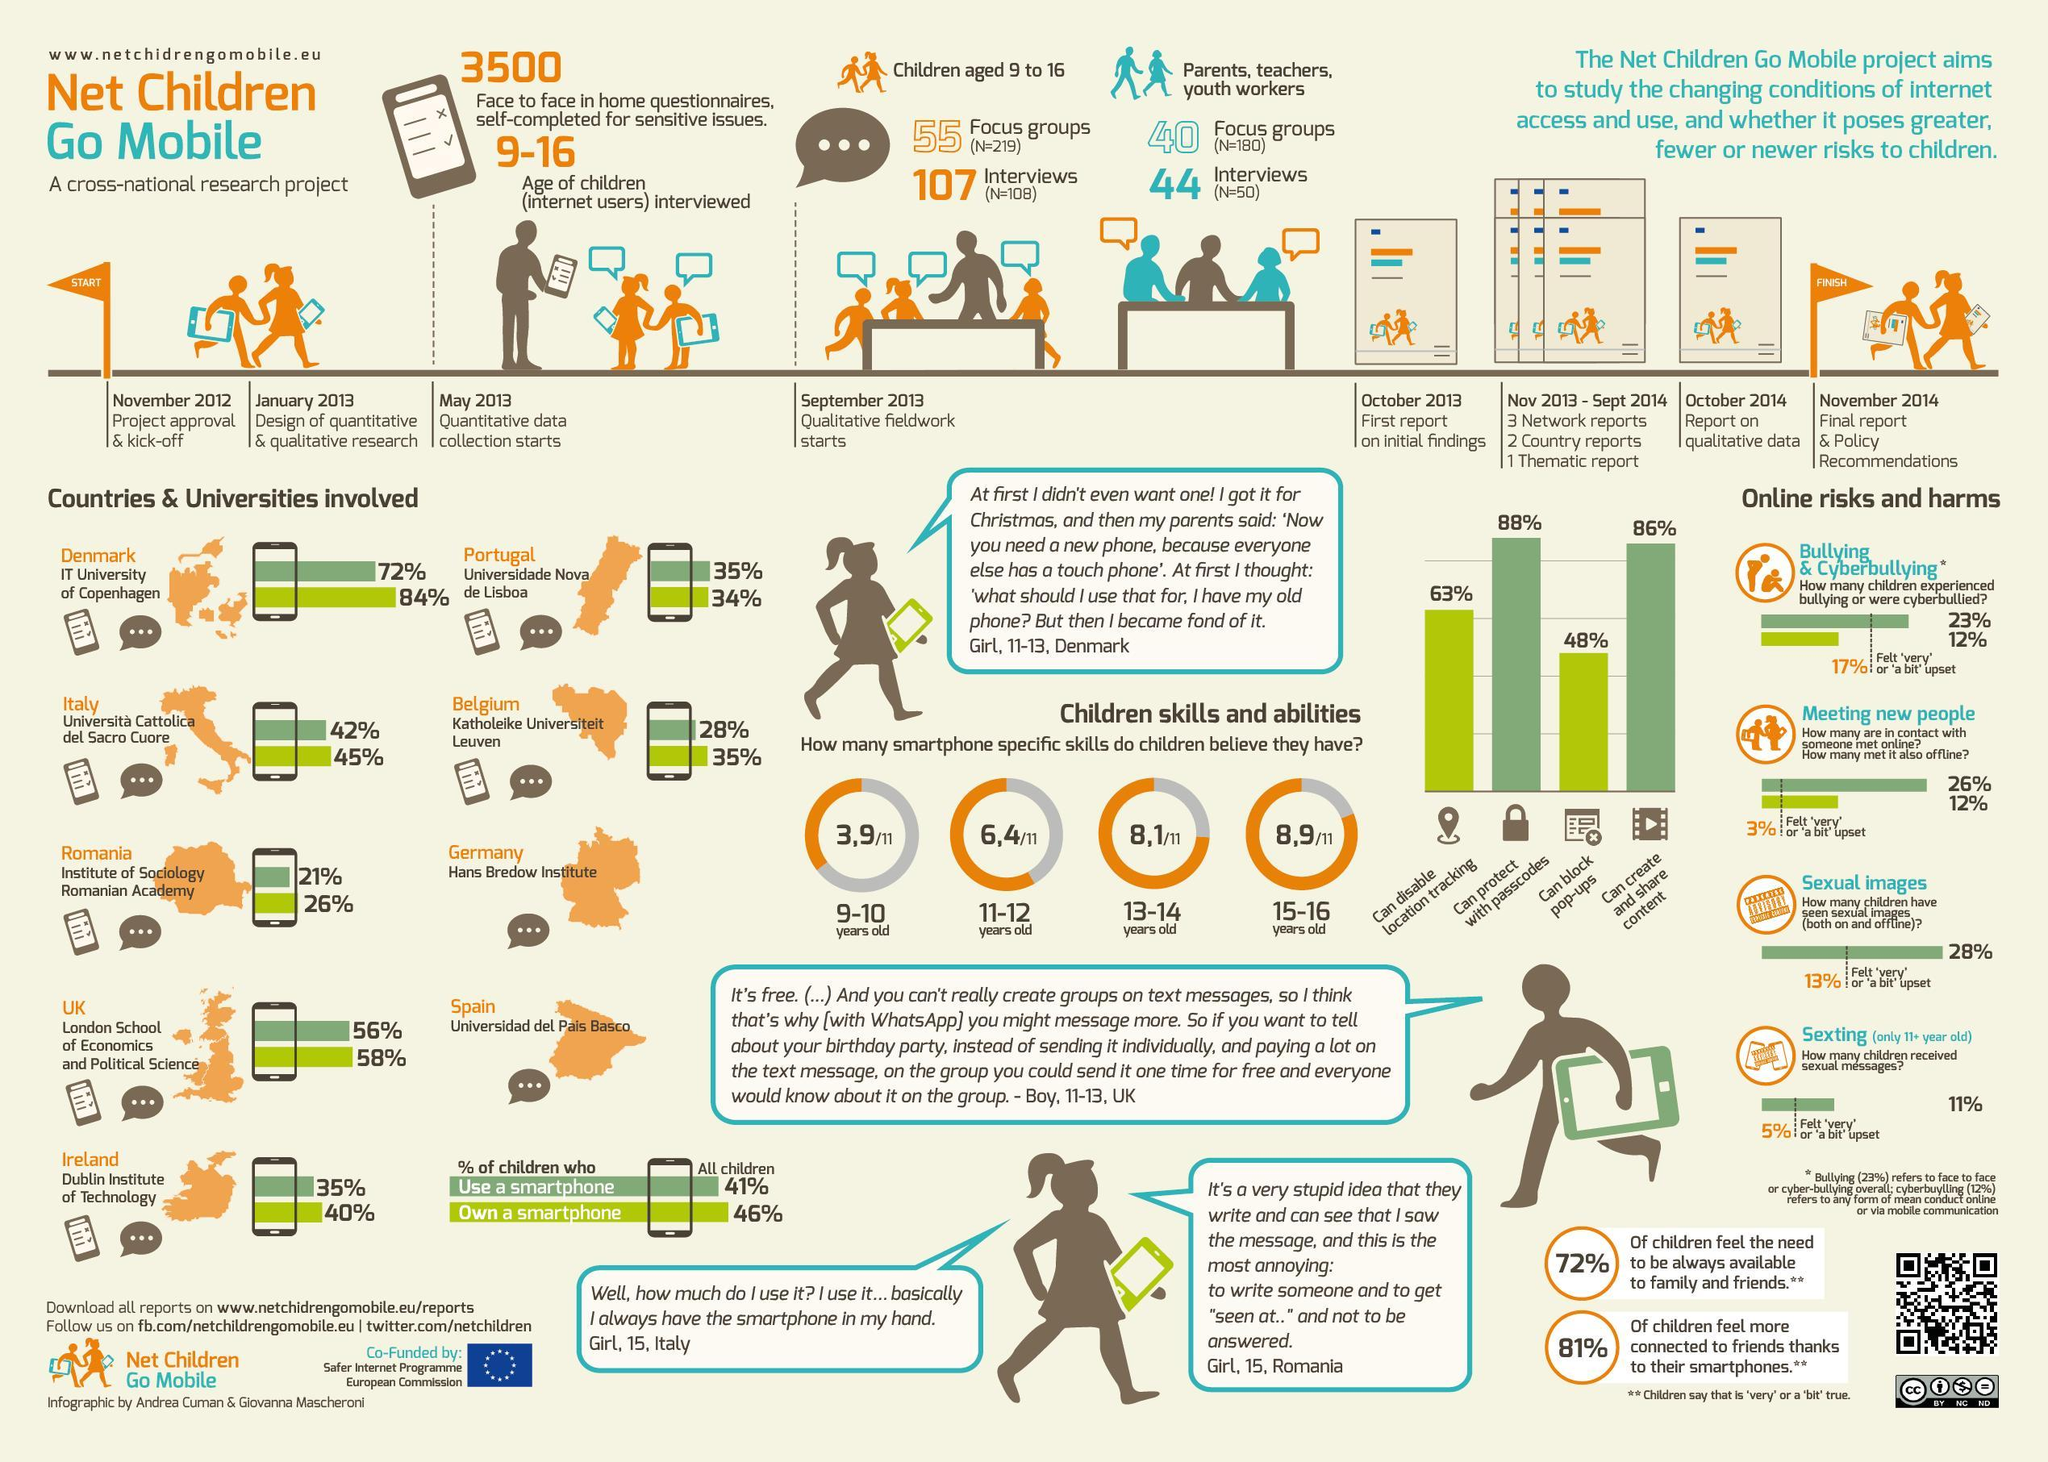When did the 'Net Children Go Mobile' project started?
Answer the question with a short phrase. November 2012 What percentage of children uses a smartphone in Institute of Sociology Romanian Academy? 21% What percentage of children own a smartphone in Dublin Institute of Technology in Ireland? 40% What percentage of children can protect their phones with passcodes? 88% What percentage of children own a smartphone in Institute of Sociology Romanian Academy? 26% How many smart phone specific skills do children in the age group of 13-14 years old have? 8,1/11 What percentage of children can block pop-ups in phones? 48% When was the first report on initial findings of the project 'Net Children Go Mobile' made? October 2013 How many smart phone specific skills do children in the age group of 11-12 years old have? 6,4/11 Which university has recorded the highest percentage of children using smartphones? IT University of Copenhagen 